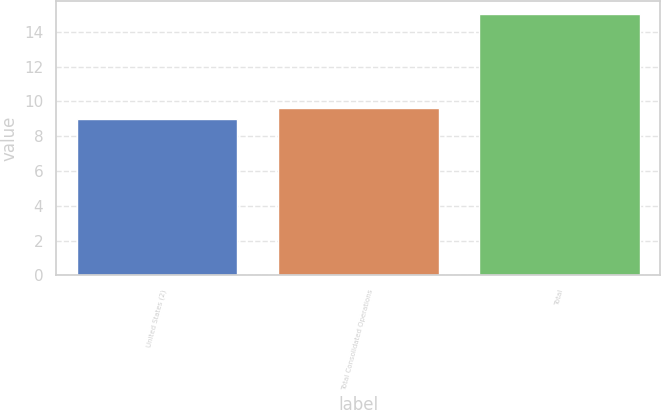<chart> <loc_0><loc_0><loc_500><loc_500><bar_chart><fcel>United States (2)<fcel>Total Consolidated Operations<fcel>Total<nl><fcel>9<fcel>9.6<fcel>15<nl></chart> 